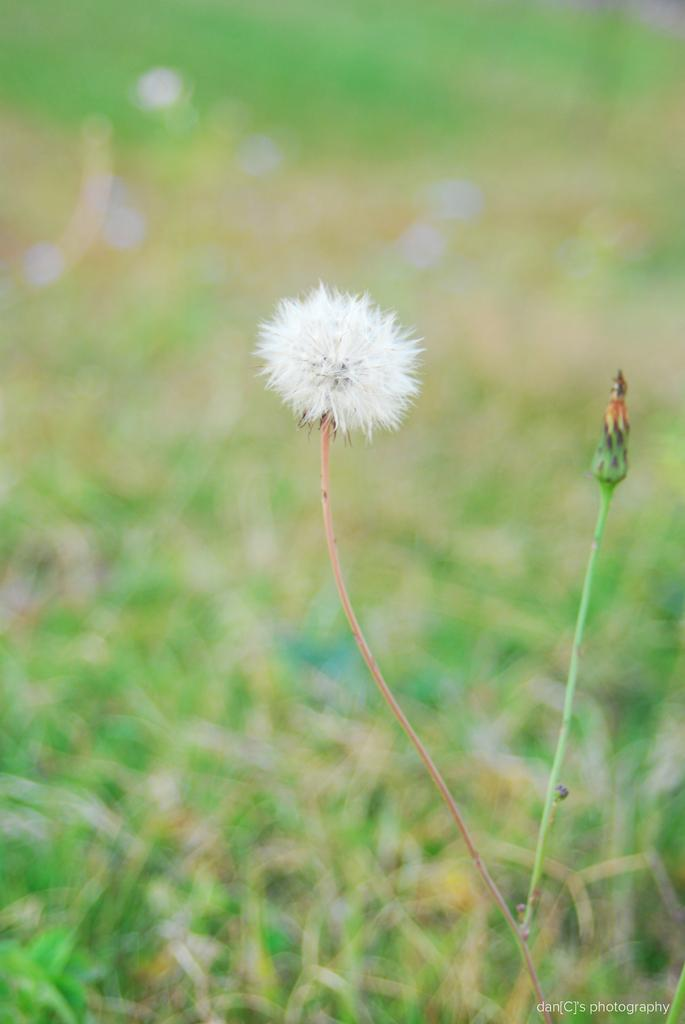What type of flower is in the image? There is a white color flower in the image. Can you describe the flower's structure? The flower has a stem. What type of cheese is visible in the image? There is no cheese present in the image; it features a white color flower with a stem. 